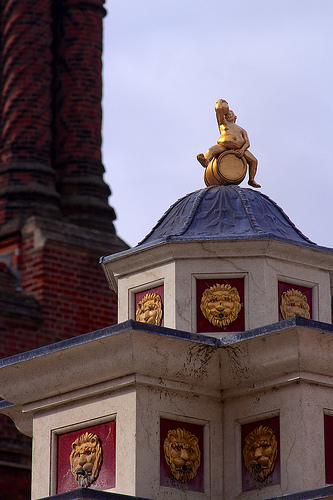<image>
Is there a sky next to the building? No. The sky is not positioned next to the building. They are located in different areas of the scene. 